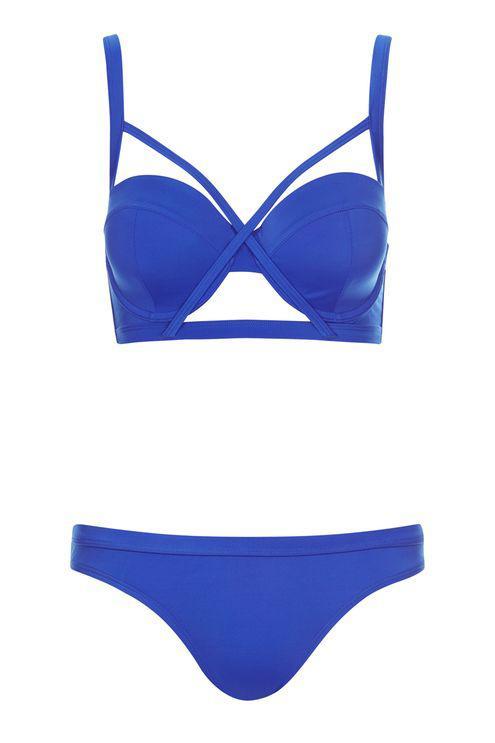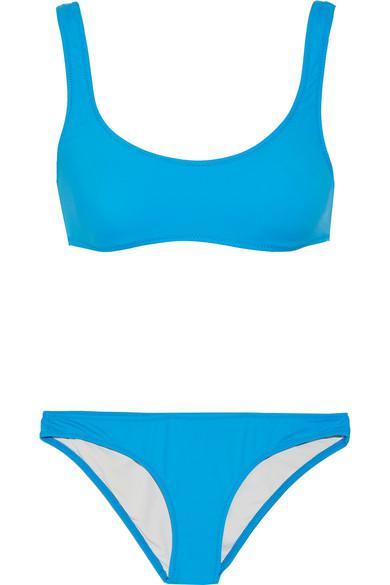The first image is the image on the left, the second image is the image on the right. Assess this claim about the two images: "All bikini tops are over-the-shoulder style, rather than tied around the neck.". Correct or not? Answer yes or no. Yes. 